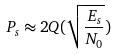<formula> <loc_0><loc_0><loc_500><loc_500>P _ { s } \approx 2 Q ( \sqrt { \frac { E _ { s } } { N _ { 0 } } } )</formula> 